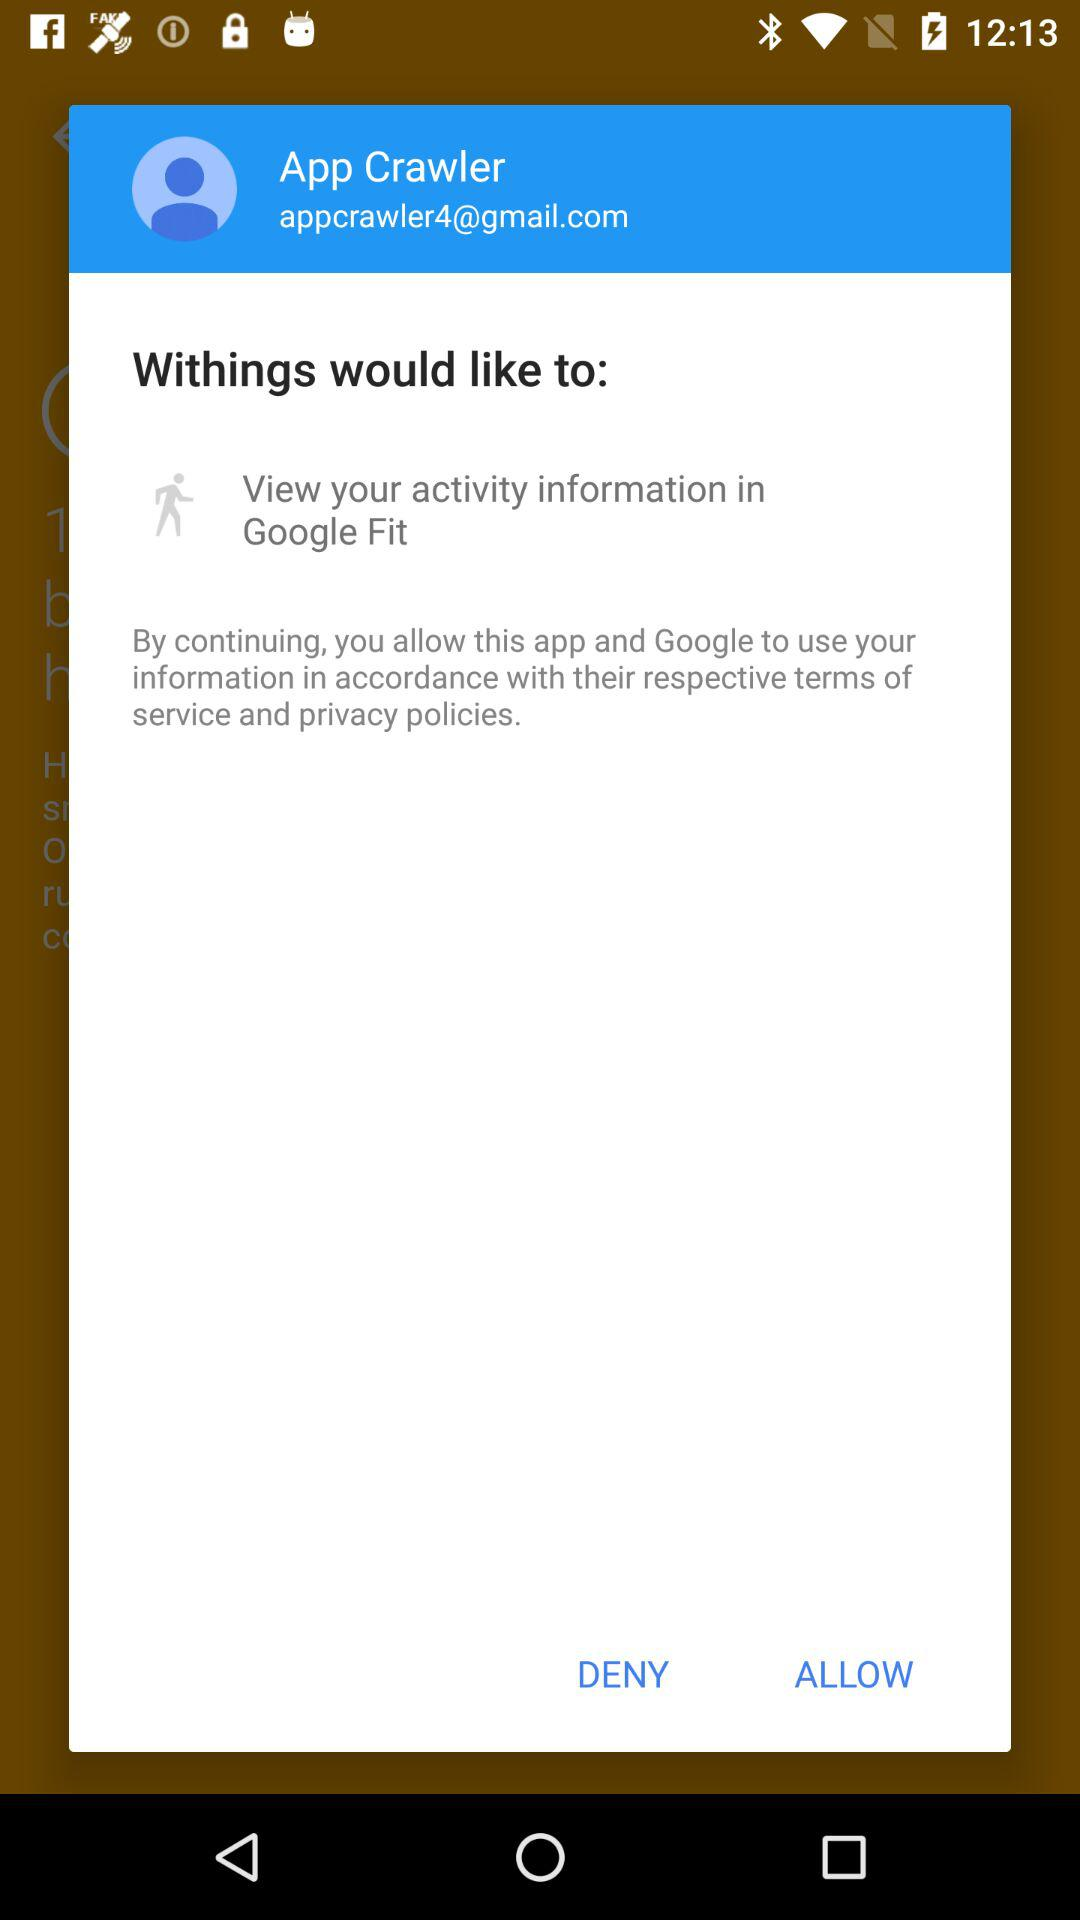What Gmail address is used? The used Gmail address is appcrawler4@gmail.com. 